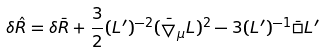Convert formula to latex. <formula><loc_0><loc_0><loc_500><loc_500>\delta \hat { R } = \delta \bar { R } + \frac { 3 } { 2 } ( L ^ { \prime } ) ^ { - 2 } ( \bar { \bigtriangledown } _ { \mu } L ) ^ { 2 } - 3 ( L ^ { \prime } ) ^ { - 1 } \bar { \square } L ^ { \prime }</formula> 